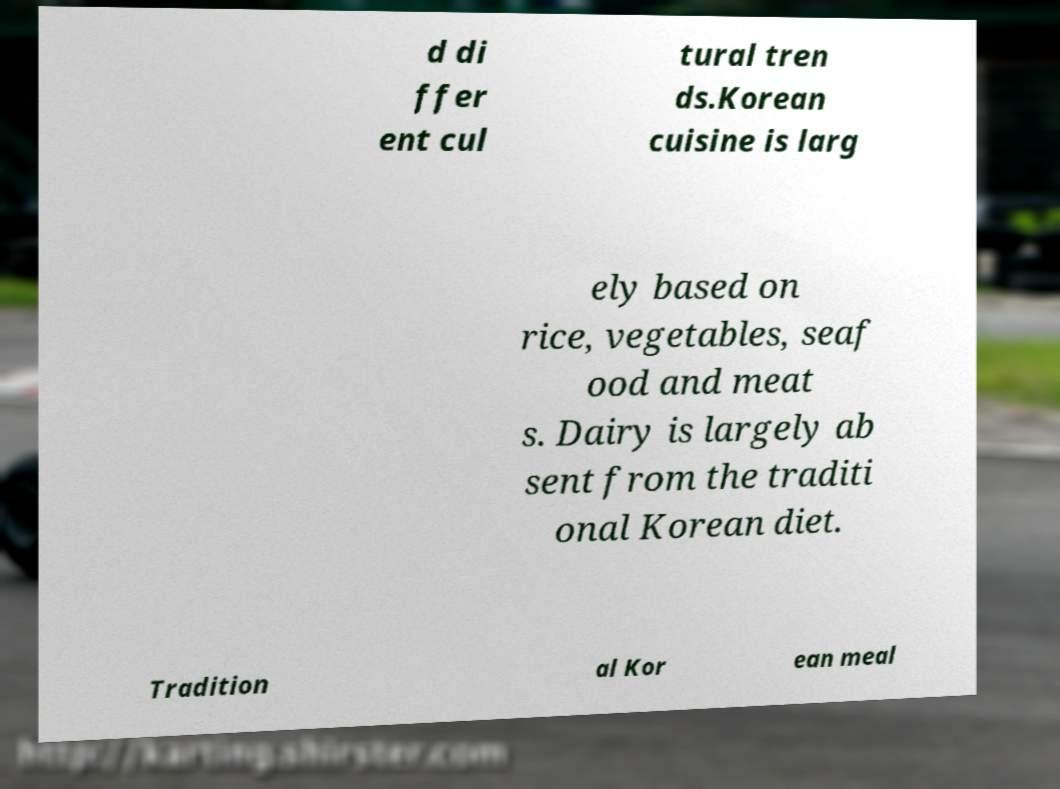For documentation purposes, I need the text within this image transcribed. Could you provide that? d di ffer ent cul tural tren ds.Korean cuisine is larg ely based on rice, vegetables, seaf ood and meat s. Dairy is largely ab sent from the traditi onal Korean diet. Tradition al Kor ean meal 